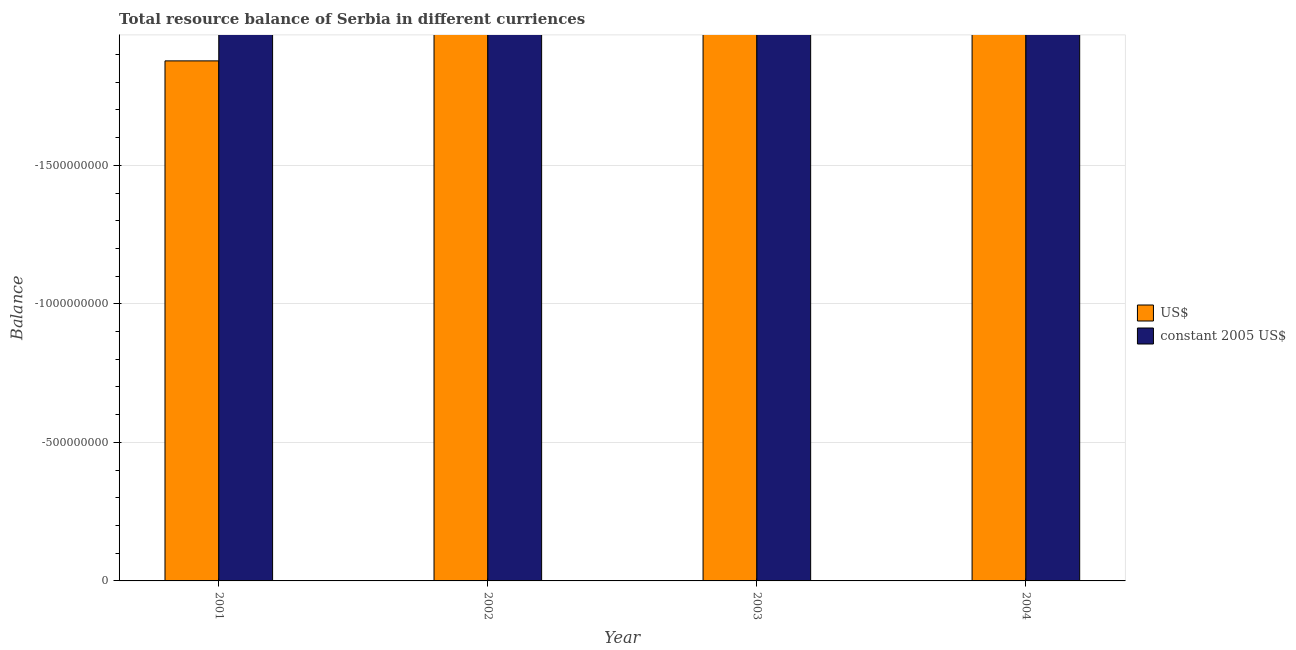Are the number of bars per tick equal to the number of legend labels?
Provide a succinct answer. No. Across all years, what is the minimum resource balance in us$?
Your answer should be compact. 0. What is the total resource balance in constant us$ in the graph?
Keep it short and to the point. 0. What is the average resource balance in us$ per year?
Ensure brevity in your answer.  0. In how many years, is the resource balance in us$ greater than the average resource balance in us$ taken over all years?
Provide a short and direct response. 0. Are all the bars in the graph horizontal?
Give a very brief answer. No. How many years are there in the graph?
Offer a terse response. 4. Does the graph contain any zero values?
Keep it short and to the point. Yes. How many legend labels are there?
Offer a terse response. 2. How are the legend labels stacked?
Provide a short and direct response. Vertical. What is the title of the graph?
Offer a terse response. Total resource balance of Serbia in different curriences. Does "Manufacturing industries and construction" appear as one of the legend labels in the graph?
Your response must be concise. No. What is the label or title of the Y-axis?
Provide a short and direct response. Balance. What is the Balance of US$ in 2001?
Offer a very short reply. 0. What is the Balance of constant 2005 US$ in 2002?
Your answer should be compact. 0. What is the Balance in US$ in 2004?
Offer a terse response. 0. What is the Balance of constant 2005 US$ in 2004?
Give a very brief answer. 0. What is the total Balance of constant 2005 US$ in the graph?
Provide a succinct answer. 0. What is the average Balance of US$ per year?
Keep it short and to the point. 0. What is the average Balance of constant 2005 US$ per year?
Keep it short and to the point. 0. 